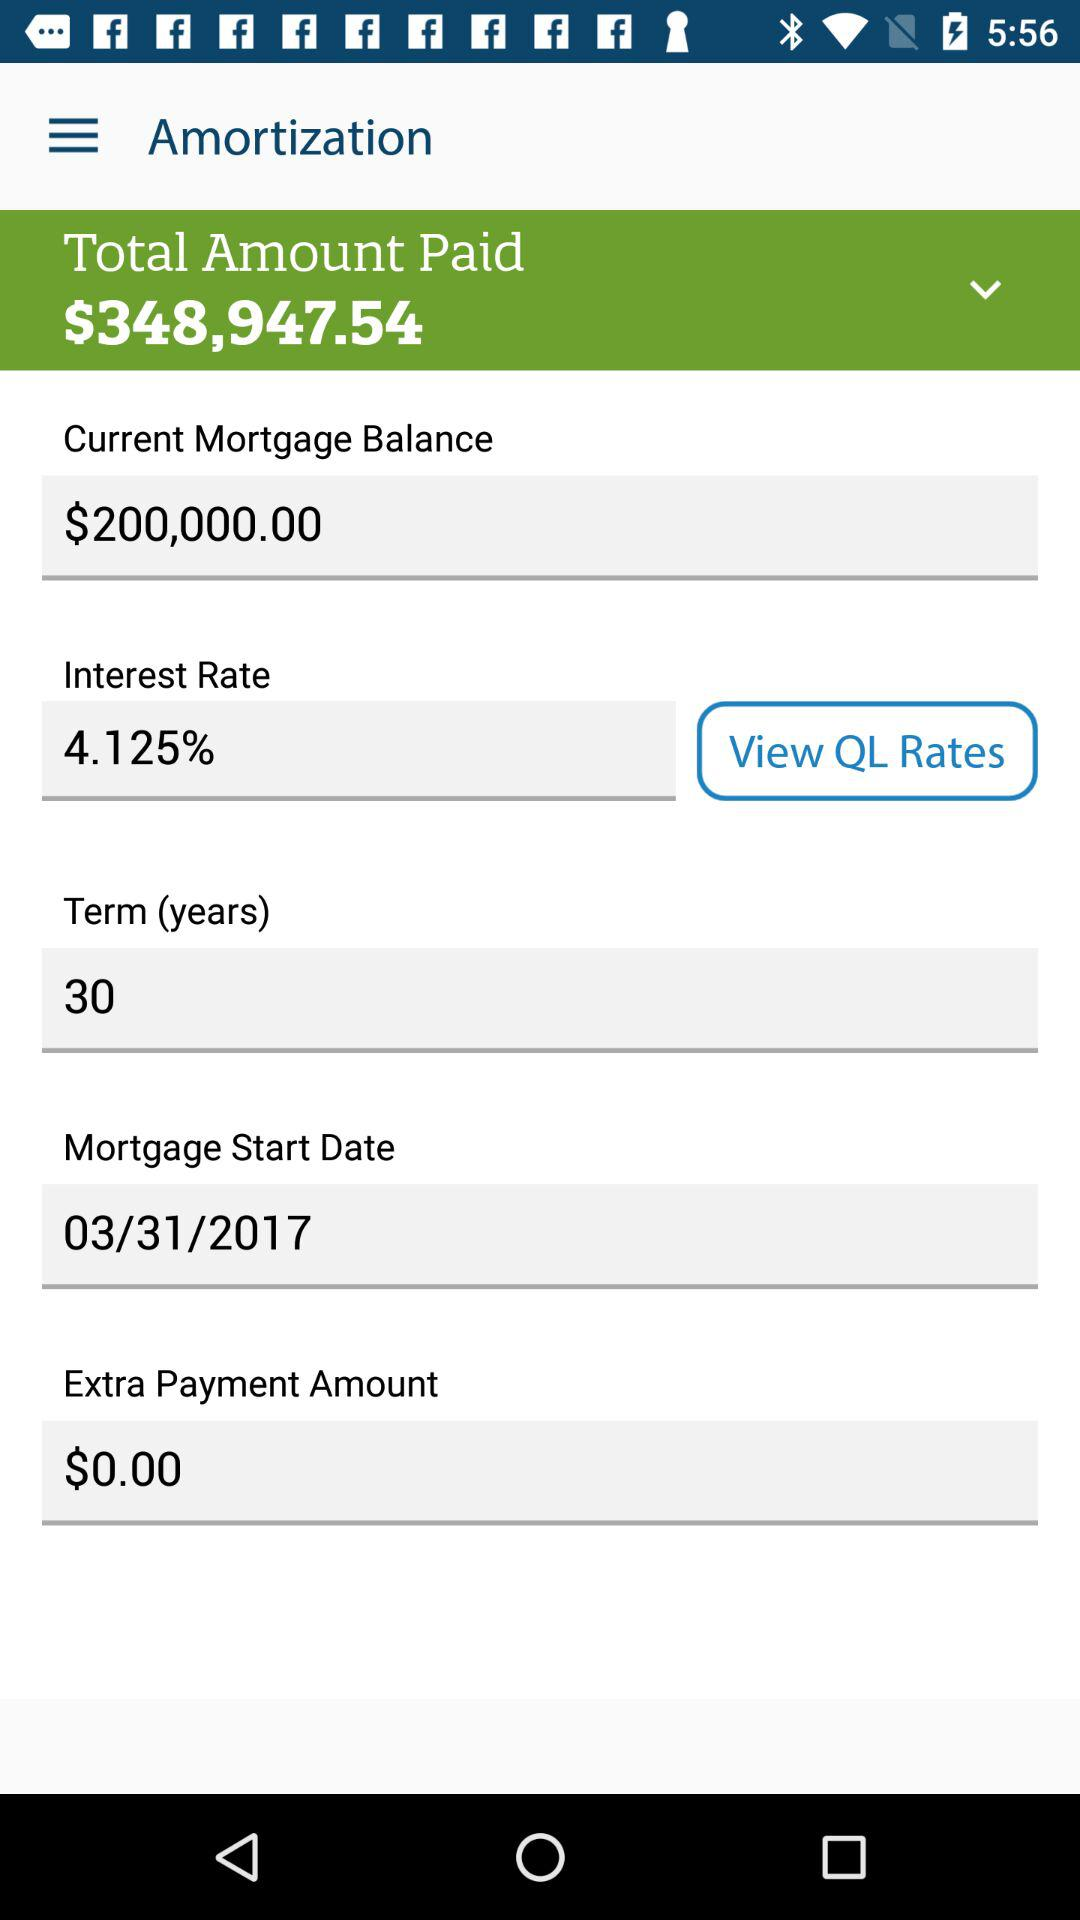What is the interest rate? The interest rate is 4.125%. 